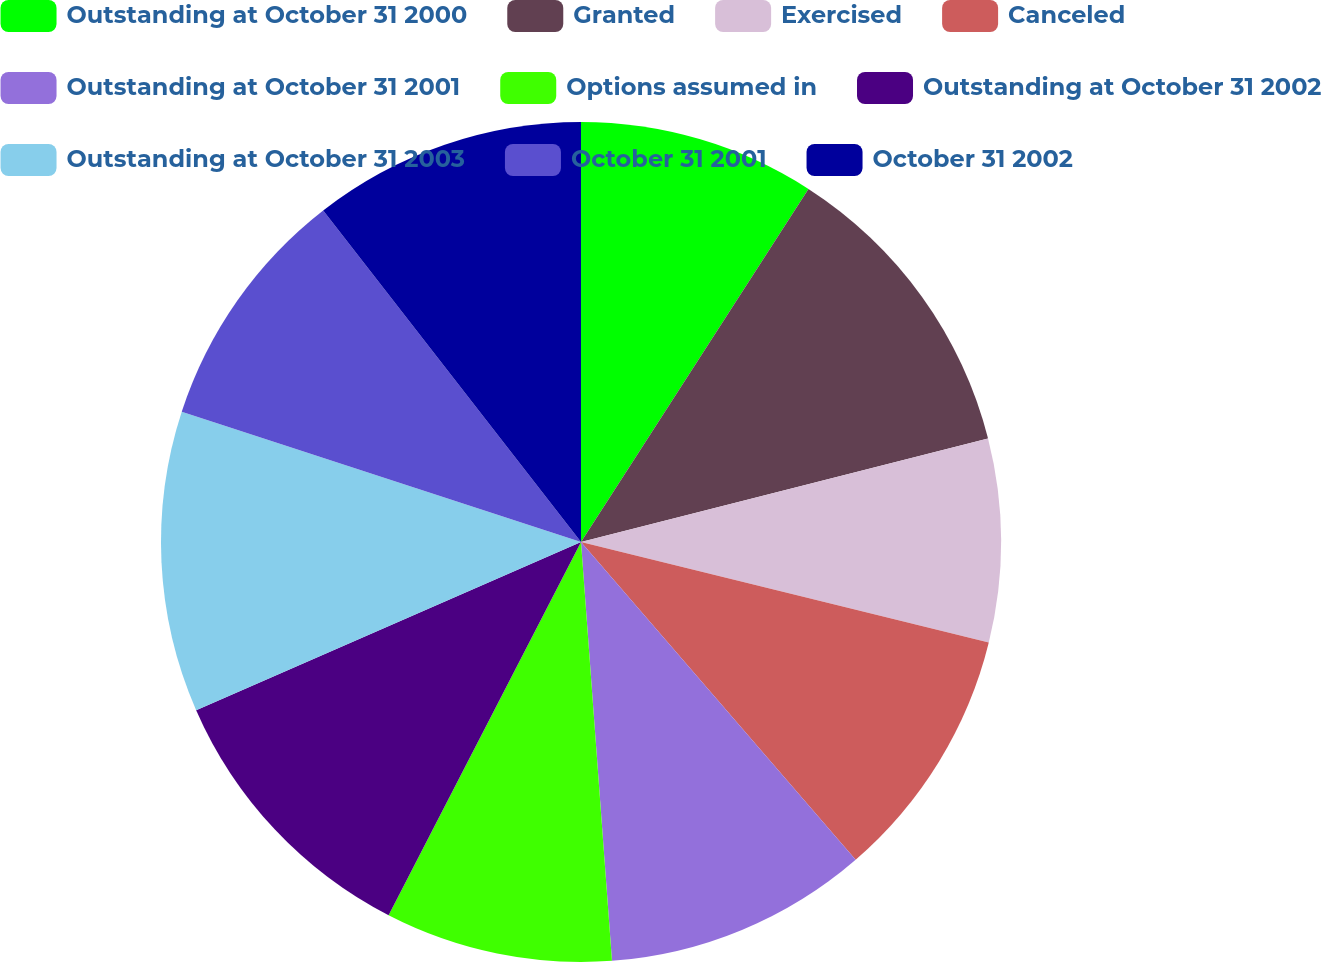Convert chart to OTSL. <chart><loc_0><loc_0><loc_500><loc_500><pie_chart><fcel>Outstanding at October 31 2000<fcel>Granted<fcel>Exercised<fcel>Canceled<fcel>Outstanding at October 31 2001<fcel>Options assumed in<fcel>Outstanding at October 31 2002<fcel>Outstanding at October 31 2003<fcel>October 31 2001<fcel>October 31 2002<nl><fcel>9.11%<fcel>11.93%<fcel>7.81%<fcel>9.81%<fcel>10.17%<fcel>8.75%<fcel>10.87%<fcel>11.58%<fcel>9.46%<fcel>10.52%<nl></chart> 